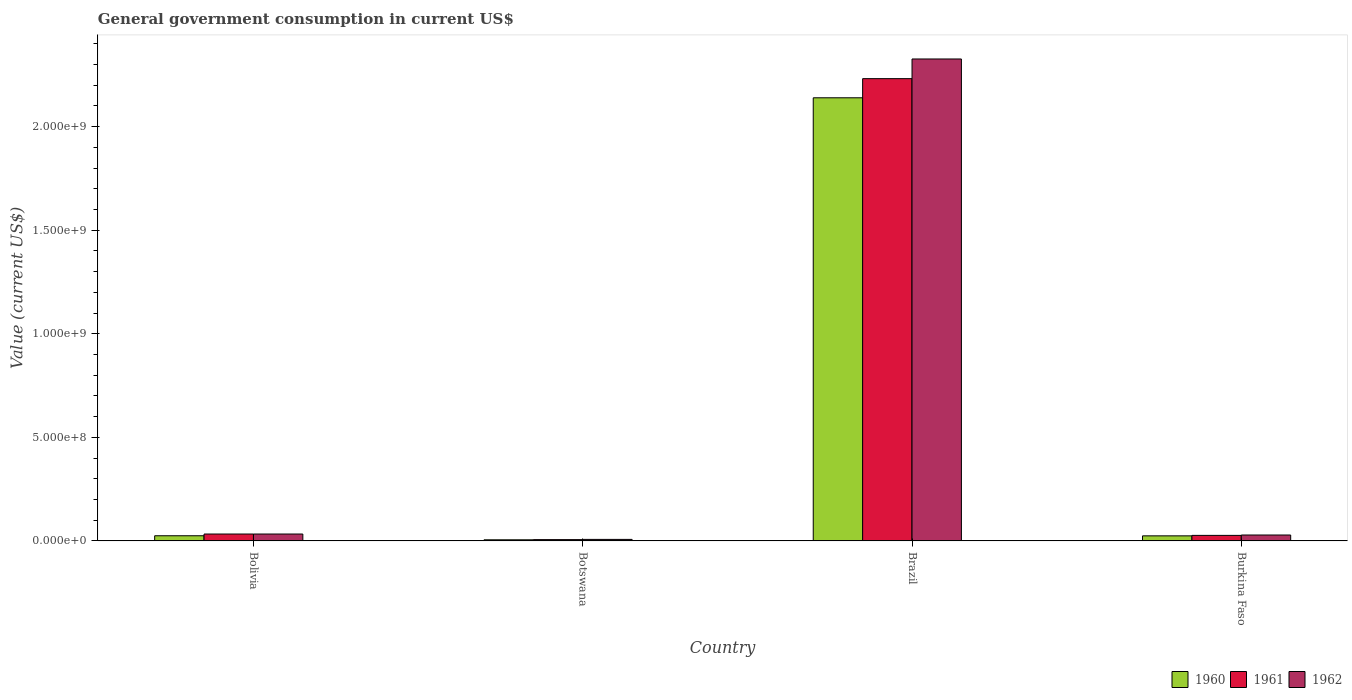How many different coloured bars are there?
Your answer should be compact. 3. How many groups of bars are there?
Provide a succinct answer. 4. Are the number of bars per tick equal to the number of legend labels?
Make the answer very short. Yes. Are the number of bars on each tick of the X-axis equal?
Provide a short and direct response. Yes. What is the label of the 3rd group of bars from the left?
Keep it short and to the point. Brazil. What is the government conusmption in 1962 in Botswana?
Give a very brief answer. 7.45e+06. Across all countries, what is the maximum government conusmption in 1961?
Your answer should be compact. 2.23e+09. Across all countries, what is the minimum government conusmption in 1960?
Provide a short and direct response. 5.52e+06. In which country was the government conusmption in 1960 maximum?
Ensure brevity in your answer.  Brazil. In which country was the government conusmption in 1962 minimum?
Your answer should be compact. Botswana. What is the total government conusmption in 1962 in the graph?
Your answer should be very brief. 2.40e+09. What is the difference between the government conusmption in 1960 in Bolivia and that in Botswana?
Keep it short and to the point. 1.95e+07. What is the difference between the government conusmption in 1962 in Botswana and the government conusmption in 1961 in Burkina Faso?
Provide a succinct answer. -1.94e+07. What is the average government conusmption in 1962 per country?
Provide a succinct answer. 5.99e+08. What is the difference between the government conusmption of/in 1960 and government conusmption of/in 1962 in Brazil?
Offer a very short reply. -1.87e+08. In how many countries, is the government conusmption in 1960 greater than 700000000 US$?
Ensure brevity in your answer.  1. What is the ratio of the government conusmption in 1962 in Bolivia to that in Botswana?
Give a very brief answer. 4.48. Is the difference between the government conusmption in 1960 in Botswana and Brazil greater than the difference between the government conusmption in 1962 in Botswana and Brazil?
Keep it short and to the point. Yes. What is the difference between the highest and the second highest government conusmption in 1960?
Give a very brief answer. 5.02e+05. What is the difference between the highest and the lowest government conusmption in 1962?
Offer a terse response. 2.32e+09. In how many countries, is the government conusmption in 1960 greater than the average government conusmption in 1960 taken over all countries?
Your answer should be very brief. 1. What does the 3rd bar from the left in Botswana represents?
Provide a short and direct response. 1962. Is it the case that in every country, the sum of the government conusmption in 1960 and government conusmption in 1961 is greater than the government conusmption in 1962?
Offer a very short reply. Yes. How many bars are there?
Give a very brief answer. 12. Does the graph contain any zero values?
Your response must be concise. No. Does the graph contain grids?
Ensure brevity in your answer.  No. How many legend labels are there?
Your answer should be very brief. 3. What is the title of the graph?
Your answer should be very brief. General government consumption in current US$. What is the label or title of the X-axis?
Your answer should be very brief. Country. What is the label or title of the Y-axis?
Provide a succinct answer. Value (current US$). What is the Value (current US$) of 1960 in Bolivia?
Your answer should be compact. 2.50e+07. What is the Value (current US$) of 1961 in Bolivia?
Keep it short and to the point. 3.34e+07. What is the Value (current US$) in 1962 in Bolivia?
Give a very brief answer. 3.34e+07. What is the Value (current US$) of 1960 in Botswana?
Offer a terse response. 5.52e+06. What is the Value (current US$) in 1961 in Botswana?
Give a very brief answer. 6.40e+06. What is the Value (current US$) of 1962 in Botswana?
Make the answer very short. 7.45e+06. What is the Value (current US$) of 1960 in Brazil?
Your answer should be very brief. 2.14e+09. What is the Value (current US$) of 1961 in Brazil?
Make the answer very short. 2.23e+09. What is the Value (current US$) of 1962 in Brazil?
Offer a terse response. 2.33e+09. What is the Value (current US$) of 1960 in Burkina Faso?
Your response must be concise. 2.45e+07. What is the Value (current US$) of 1961 in Burkina Faso?
Make the answer very short. 2.68e+07. What is the Value (current US$) of 1962 in Burkina Faso?
Ensure brevity in your answer.  2.87e+07. Across all countries, what is the maximum Value (current US$) of 1960?
Make the answer very short. 2.14e+09. Across all countries, what is the maximum Value (current US$) in 1961?
Make the answer very short. 2.23e+09. Across all countries, what is the maximum Value (current US$) of 1962?
Keep it short and to the point. 2.33e+09. Across all countries, what is the minimum Value (current US$) in 1960?
Provide a succinct answer. 5.52e+06. Across all countries, what is the minimum Value (current US$) of 1961?
Your answer should be compact. 6.40e+06. Across all countries, what is the minimum Value (current US$) in 1962?
Make the answer very short. 7.45e+06. What is the total Value (current US$) in 1960 in the graph?
Give a very brief answer. 2.19e+09. What is the total Value (current US$) of 1961 in the graph?
Your response must be concise. 2.30e+09. What is the total Value (current US$) of 1962 in the graph?
Keep it short and to the point. 2.40e+09. What is the difference between the Value (current US$) of 1960 in Bolivia and that in Botswana?
Your answer should be very brief. 1.95e+07. What is the difference between the Value (current US$) in 1961 in Bolivia and that in Botswana?
Offer a terse response. 2.70e+07. What is the difference between the Value (current US$) of 1962 in Bolivia and that in Botswana?
Your answer should be very brief. 2.59e+07. What is the difference between the Value (current US$) in 1960 in Bolivia and that in Brazil?
Ensure brevity in your answer.  -2.11e+09. What is the difference between the Value (current US$) in 1961 in Bolivia and that in Brazil?
Offer a terse response. -2.20e+09. What is the difference between the Value (current US$) in 1962 in Bolivia and that in Brazil?
Provide a short and direct response. -2.29e+09. What is the difference between the Value (current US$) in 1960 in Bolivia and that in Burkina Faso?
Offer a very short reply. 5.02e+05. What is the difference between the Value (current US$) of 1961 in Bolivia and that in Burkina Faso?
Your answer should be compact. 6.58e+06. What is the difference between the Value (current US$) in 1962 in Bolivia and that in Burkina Faso?
Provide a short and direct response. 4.74e+06. What is the difference between the Value (current US$) of 1960 in Botswana and that in Brazil?
Your answer should be very brief. -2.13e+09. What is the difference between the Value (current US$) in 1961 in Botswana and that in Brazil?
Ensure brevity in your answer.  -2.23e+09. What is the difference between the Value (current US$) of 1962 in Botswana and that in Brazil?
Offer a terse response. -2.32e+09. What is the difference between the Value (current US$) in 1960 in Botswana and that in Burkina Faso?
Your answer should be very brief. -1.90e+07. What is the difference between the Value (current US$) in 1961 in Botswana and that in Burkina Faso?
Provide a short and direct response. -2.04e+07. What is the difference between the Value (current US$) in 1962 in Botswana and that in Burkina Faso?
Offer a terse response. -2.12e+07. What is the difference between the Value (current US$) in 1960 in Brazil and that in Burkina Faso?
Offer a terse response. 2.11e+09. What is the difference between the Value (current US$) in 1961 in Brazil and that in Burkina Faso?
Keep it short and to the point. 2.20e+09. What is the difference between the Value (current US$) of 1962 in Brazil and that in Burkina Faso?
Make the answer very short. 2.30e+09. What is the difference between the Value (current US$) in 1960 in Bolivia and the Value (current US$) in 1961 in Botswana?
Offer a very short reply. 1.86e+07. What is the difference between the Value (current US$) in 1960 in Bolivia and the Value (current US$) in 1962 in Botswana?
Give a very brief answer. 1.76e+07. What is the difference between the Value (current US$) of 1961 in Bolivia and the Value (current US$) of 1962 in Botswana?
Give a very brief answer. 2.59e+07. What is the difference between the Value (current US$) in 1960 in Bolivia and the Value (current US$) in 1961 in Brazil?
Provide a succinct answer. -2.21e+09. What is the difference between the Value (current US$) in 1960 in Bolivia and the Value (current US$) in 1962 in Brazil?
Give a very brief answer. -2.30e+09. What is the difference between the Value (current US$) of 1961 in Bolivia and the Value (current US$) of 1962 in Brazil?
Your answer should be compact. -2.29e+09. What is the difference between the Value (current US$) in 1960 in Bolivia and the Value (current US$) in 1961 in Burkina Faso?
Make the answer very short. -1.76e+06. What is the difference between the Value (current US$) of 1960 in Bolivia and the Value (current US$) of 1962 in Burkina Faso?
Make the answer very short. -3.61e+06. What is the difference between the Value (current US$) in 1961 in Bolivia and the Value (current US$) in 1962 in Burkina Faso?
Offer a terse response. 4.74e+06. What is the difference between the Value (current US$) of 1960 in Botswana and the Value (current US$) of 1961 in Brazil?
Your answer should be compact. -2.23e+09. What is the difference between the Value (current US$) in 1960 in Botswana and the Value (current US$) in 1962 in Brazil?
Provide a short and direct response. -2.32e+09. What is the difference between the Value (current US$) of 1961 in Botswana and the Value (current US$) of 1962 in Brazil?
Your answer should be compact. -2.32e+09. What is the difference between the Value (current US$) of 1960 in Botswana and the Value (current US$) of 1961 in Burkina Faso?
Make the answer very short. -2.13e+07. What is the difference between the Value (current US$) in 1960 in Botswana and the Value (current US$) in 1962 in Burkina Faso?
Provide a succinct answer. -2.31e+07. What is the difference between the Value (current US$) of 1961 in Botswana and the Value (current US$) of 1962 in Burkina Faso?
Offer a terse response. -2.23e+07. What is the difference between the Value (current US$) of 1960 in Brazil and the Value (current US$) of 1961 in Burkina Faso?
Your answer should be very brief. 2.11e+09. What is the difference between the Value (current US$) in 1960 in Brazil and the Value (current US$) in 1962 in Burkina Faso?
Provide a succinct answer. 2.11e+09. What is the difference between the Value (current US$) in 1961 in Brazil and the Value (current US$) in 1962 in Burkina Faso?
Ensure brevity in your answer.  2.20e+09. What is the average Value (current US$) of 1960 per country?
Offer a terse response. 5.49e+08. What is the average Value (current US$) in 1961 per country?
Offer a very short reply. 5.74e+08. What is the average Value (current US$) in 1962 per country?
Offer a terse response. 5.99e+08. What is the difference between the Value (current US$) in 1960 and Value (current US$) in 1961 in Bolivia?
Give a very brief answer. -8.35e+06. What is the difference between the Value (current US$) in 1960 and Value (current US$) in 1962 in Bolivia?
Give a very brief answer. -8.35e+06. What is the difference between the Value (current US$) in 1960 and Value (current US$) in 1961 in Botswana?
Offer a terse response. -8.82e+05. What is the difference between the Value (current US$) in 1960 and Value (current US$) in 1962 in Botswana?
Your answer should be compact. -1.94e+06. What is the difference between the Value (current US$) of 1961 and Value (current US$) of 1962 in Botswana?
Offer a very short reply. -1.06e+06. What is the difference between the Value (current US$) in 1960 and Value (current US$) in 1961 in Brazil?
Give a very brief answer. -9.24e+07. What is the difference between the Value (current US$) in 1960 and Value (current US$) in 1962 in Brazil?
Your answer should be compact. -1.87e+08. What is the difference between the Value (current US$) of 1961 and Value (current US$) of 1962 in Brazil?
Make the answer very short. -9.50e+07. What is the difference between the Value (current US$) in 1960 and Value (current US$) in 1961 in Burkina Faso?
Provide a short and direct response. -2.27e+06. What is the difference between the Value (current US$) of 1960 and Value (current US$) of 1962 in Burkina Faso?
Ensure brevity in your answer.  -4.11e+06. What is the difference between the Value (current US$) in 1961 and Value (current US$) in 1962 in Burkina Faso?
Offer a terse response. -1.84e+06. What is the ratio of the Value (current US$) of 1960 in Bolivia to that in Botswana?
Your response must be concise. 4.54. What is the ratio of the Value (current US$) of 1961 in Bolivia to that in Botswana?
Your response must be concise. 5.22. What is the ratio of the Value (current US$) of 1962 in Bolivia to that in Botswana?
Give a very brief answer. 4.48. What is the ratio of the Value (current US$) of 1960 in Bolivia to that in Brazil?
Provide a short and direct response. 0.01. What is the ratio of the Value (current US$) of 1961 in Bolivia to that in Brazil?
Make the answer very short. 0.01. What is the ratio of the Value (current US$) in 1962 in Bolivia to that in Brazil?
Your response must be concise. 0.01. What is the ratio of the Value (current US$) in 1960 in Bolivia to that in Burkina Faso?
Your response must be concise. 1.02. What is the ratio of the Value (current US$) in 1961 in Bolivia to that in Burkina Faso?
Make the answer very short. 1.25. What is the ratio of the Value (current US$) of 1962 in Bolivia to that in Burkina Faso?
Keep it short and to the point. 1.17. What is the ratio of the Value (current US$) of 1960 in Botswana to that in Brazil?
Your answer should be compact. 0. What is the ratio of the Value (current US$) of 1961 in Botswana to that in Brazil?
Your answer should be compact. 0. What is the ratio of the Value (current US$) of 1962 in Botswana to that in Brazil?
Offer a very short reply. 0. What is the ratio of the Value (current US$) of 1960 in Botswana to that in Burkina Faso?
Keep it short and to the point. 0.22. What is the ratio of the Value (current US$) in 1961 in Botswana to that in Burkina Faso?
Offer a terse response. 0.24. What is the ratio of the Value (current US$) in 1962 in Botswana to that in Burkina Faso?
Provide a short and direct response. 0.26. What is the ratio of the Value (current US$) of 1960 in Brazil to that in Burkina Faso?
Make the answer very short. 87.16. What is the ratio of the Value (current US$) of 1961 in Brazil to that in Burkina Faso?
Provide a succinct answer. 83.24. What is the ratio of the Value (current US$) of 1962 in Brazil to that in Burkina Faso?
Provide a succinct answer. 81.2. What is the difference between the highest and the second highest Value (current US$) in 1960?
Keep it short and to the point. 2.11e+09. What is the difference between the highest and the second highest Value (current US$) of 1961?
Offer a terse response. 2.20e+09. What is the difference between the highest and the second highest Value (current US$) of 1962?
Your response must be concise. 2.29e+09. What is the difference between the highest and the lowest Value (current US$) in 1960?
Offer a terse response. 2.13e+09. What is the difference between the highest and the lowest Value (current US$) of 1961?
Your answer should be very brief. 2.23e+09. What is the difference between the highest and the lowest Value (current US$) of 1962?
Provide a succinct answer. 2.32e+09. 